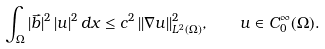<formula> <loc_0><loc_0><loc_500><loc_500>\int _ { \Omega } | \vec { b } | ^ { 2 } \, | u | ^ { 2 } \, d x \leq c ^ { 2 } \, | | \nabla u | | ^ { 2 } _ { L ^ { 2 } ( \Omega ) } , \quad u \in C ^ { \infty } _ { 0 } ( \Omega ) .</formula> 